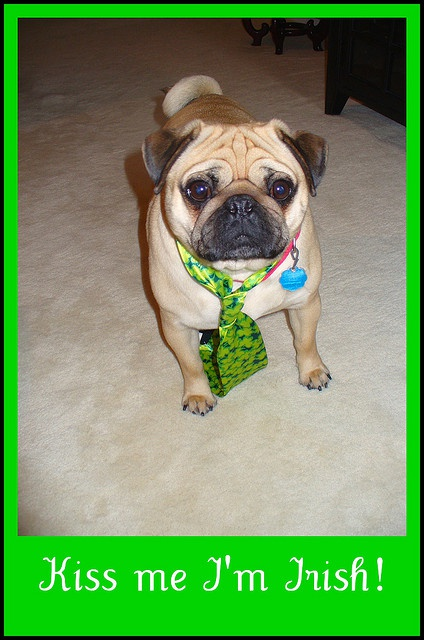Describe the objects in this image and their specific colors. I can see dog in black, lightgray, tan, and darkgray tones, tie in black, olive, and darkgreen tones, and chair in black and gray tones in this image. 